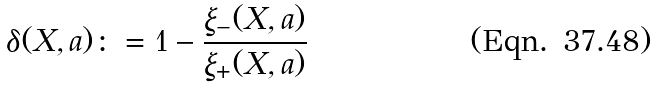Convert formula to latex. <formula><loc_0><loc_0><loc_500><loc_500>\delta ( X , a ) \colon = 1 - \frac { \xi _ { - } ( X , a ) } { \xi _ { + } ( X , a ) }</formula> 